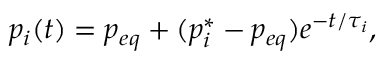Convert formula to latex. <formula><loc_0><loc_0><loc_500><loc_500>p _ { i } ( t ) = p _ { e q } + ( p _ { i } ^ { * } - p _ { e q } ) e ^ { - t / \tau _ { i } } ,</formula> 